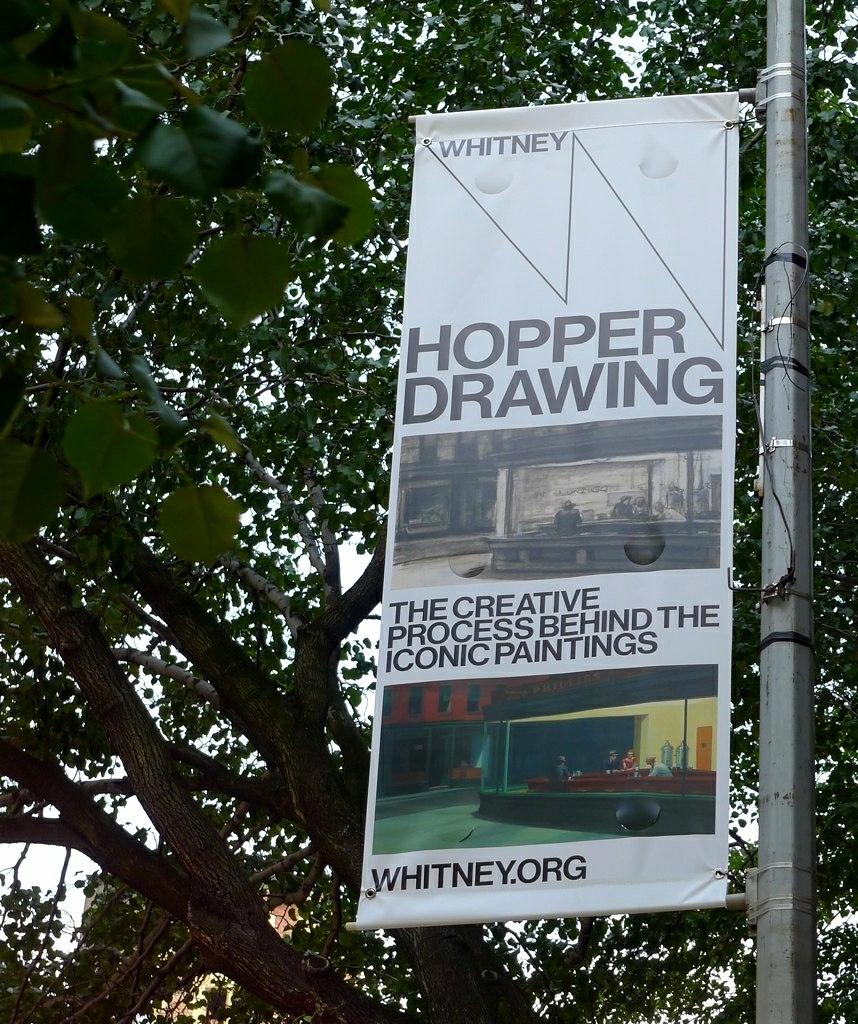What is hanging from the pole in the image? There is a banner in the image that is attached to a pole. What can be seen near the banner in the image? There is a tree in the image. Can you describe the tree in the image? The tree has branches and leaves. What type of needle is being used to sew the leaves on the tree in the image? There is no needle present in the image, and the leaves on the tree are not being sewn. 